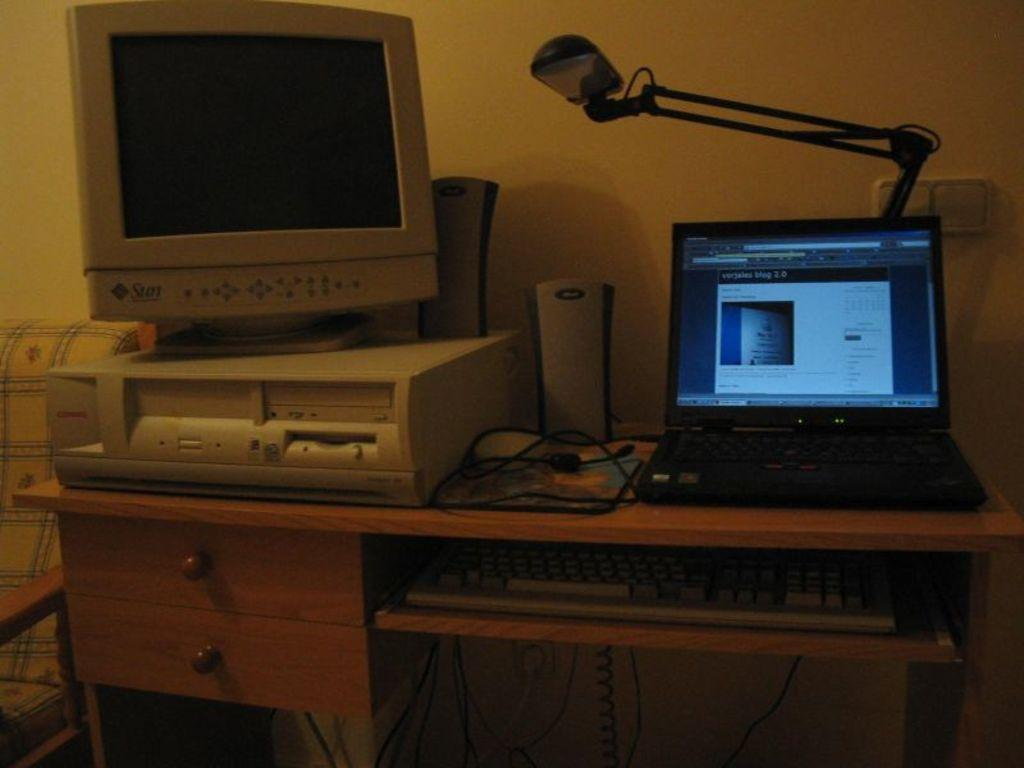What type of furniture is in the image? There is a table in the image. What electronic devices are on the table? A monitor, a laptop, and speakers are visible on the table. What type of lighting is on the table? A table lamp is on the table. What is used for typing in the image? There is a keyboard in the image. How is the keyboard positioned on the table? The keyboard is attached to a stand. How many eyes can be seen on the kittens in the image? There are no kittens present in the image, so there are no eyes to count. --- 